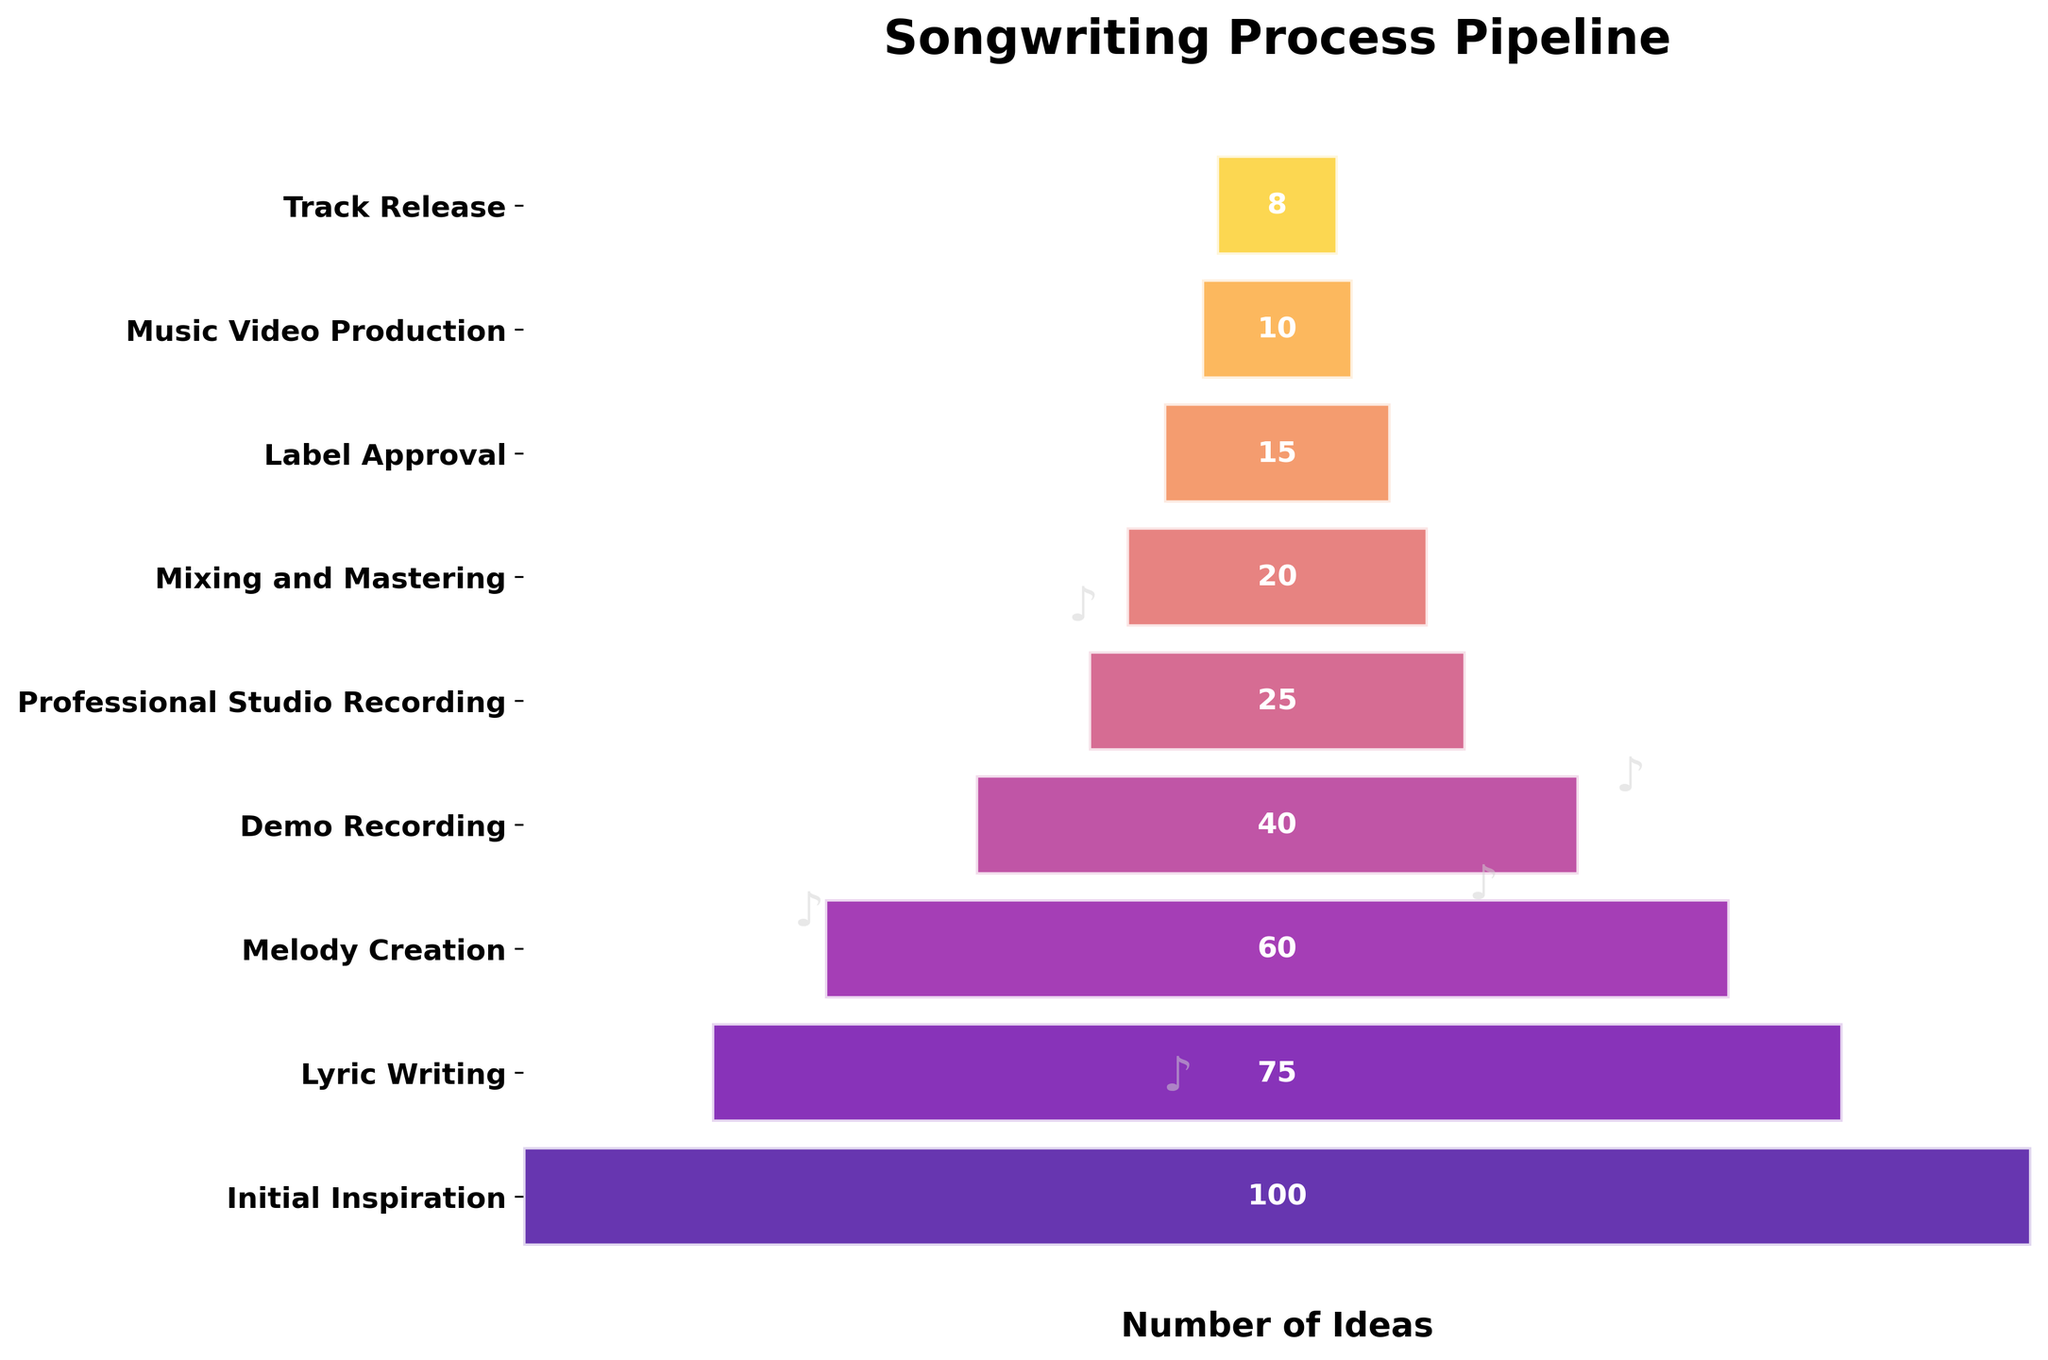What is the title of the funnel chart? The title is displayed at the top of the chart. It is written clearly in a bold, large font.
Answer: Songwriting Process Pipeline How many stages are represented in the funnel chart? Each stage is represented by a horizontal bar in the funnel chart, and counting them gives the total number of stages.
Answer: 9 Which stage has the highest number of ideas? The stage with the widest bar at the top of the funnel represents the highest number of ideas, which is the initial stage.
Answer: Initial Inspiration How many ideas make it to the final stage of Track Release? The number within the bar corresponding to the "Track Release" stage tells how many ideas make it to this final stage.
Answer: 8 What is the difference in the number of ideas between the Melody Creation stage and the Demo Recording stage? Subtract the number of ideas at the Demo Recording stage from those at the Melody Creation stage: 60 - 40.
Answer: 20 What is the average number of ideas across all the stages? Sum all the number of ideas and then divide by the number of stages: (100 + 75 + 60 + 40 + 25 + 20 + 15 + 10 + 8) / 9.
Answer: 39.2 Which stage sees the largest drop in the number of ideas compared to its previous stage? By calculating the difference between consecutive stages and identifying the largest: (Initial Inspiration to Lyric Writing: 100-75, Lyric Writing to Melody Creation: 75-60, etc.).
Answer: Demo Recording How many more ideas make it to the Professional Studio Recording stage than the Label Approval stage? Subtract the number of ideas at Label Approval stage from those at Professional Studio Recording stage: 25 - 15.
Answer: 10 Which stages have fewer than 20 ideas remaining? Look for the stages with bars shorter than or equal to 20: Mixing and Mastering, Label Approval, Music Video Production, Track Release.
Answer: 4 What is the cumulative number of ideas from the Mixing and Mastering stage to the Track Release stage? Sum the numbers from these stages: (Mixing and Mastering + Label Approval + Music Video Production + Track Release): 20 + 15 + 10 + 8.
Answer: 53 